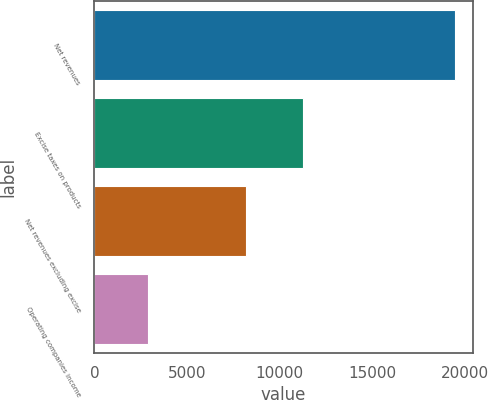<chart> <loc_0><loc_0><loc_500><loc_500><bar_chart><fcel>Net revenues<fcel>Excise taxes on products<fcel>Net revenues excluding excise<fcel>Operating companies income<nl><fcel>19469<fcel>11266<fcel>8203<fcel>2886<nl></chart> 